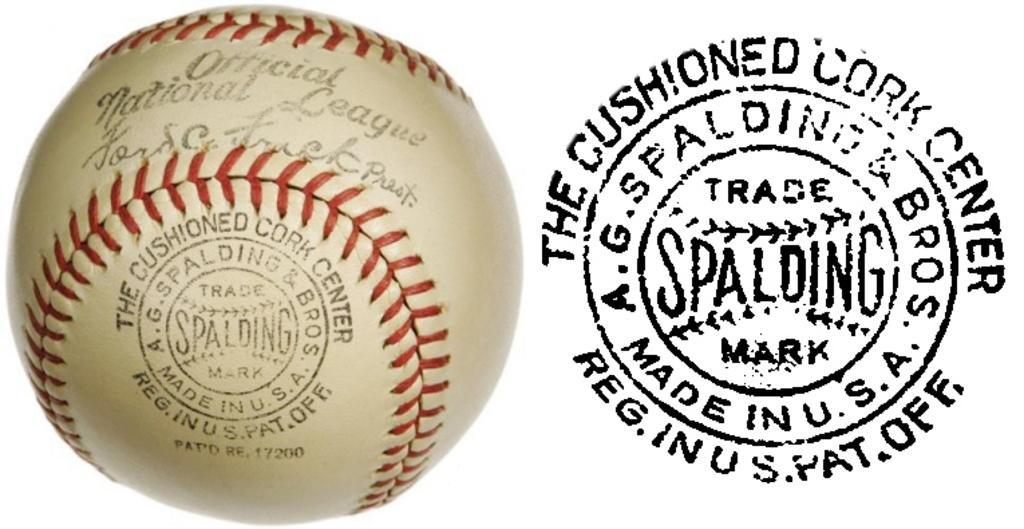In one or two sentences, can you explain what this image depicts? In this image there is a ball with some text on it and a stamp. 